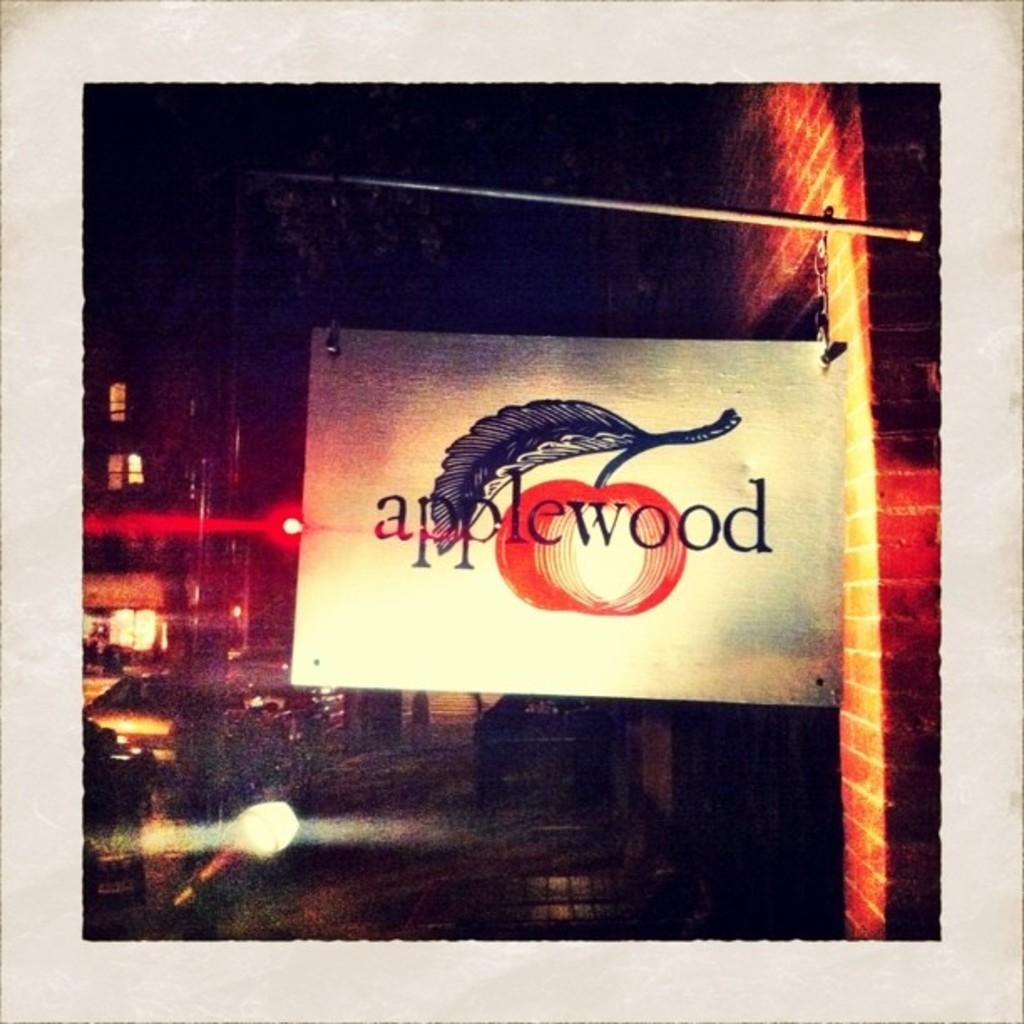What is hanged on an iron rod in the image? There is a board hanged on an iron rod in the image. How is the iron rod connected to the surroundings? The iron rod is attached to a building. What can be seen on the road in the image? There are vehicles on the road in the image. What is visible in the background of the image? There is a building in the background of the image. What type of land can be seen in the image? There is no specific type of land mentioned or visible in the image. What caused the iron rod to be attached to the building? The facts provided do not mention any cause for the iron rod's attachment to the building. 